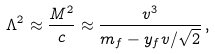Convert formula to latex. <formula><loc_0><loc_0><loc_500><loc_500>\Lambda ^ { 2 } \approx \frac { M ^ { 2 } } { c } \approx \frac { v ^ { 3 } } { m _ { f } - y _ { f } v / \sqrt { 2 } } \, ,</formula> 